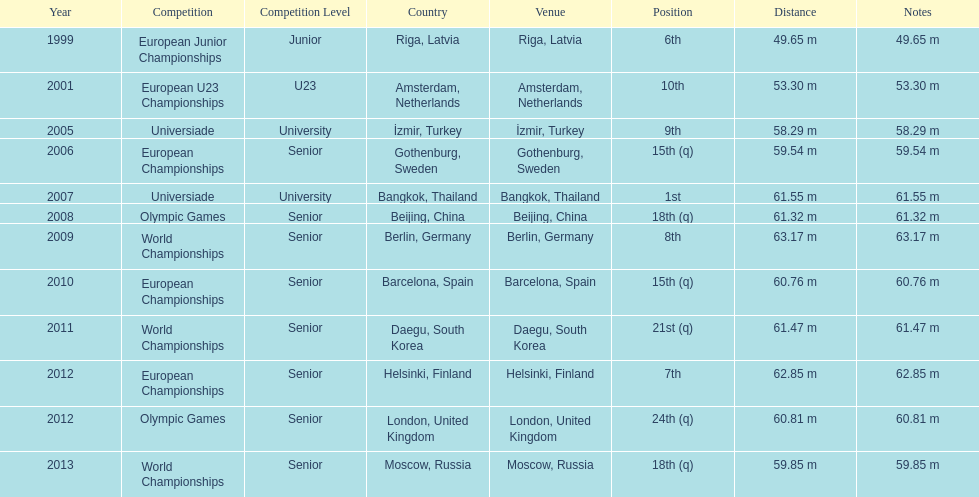Which year held the most competitions? 2012. 